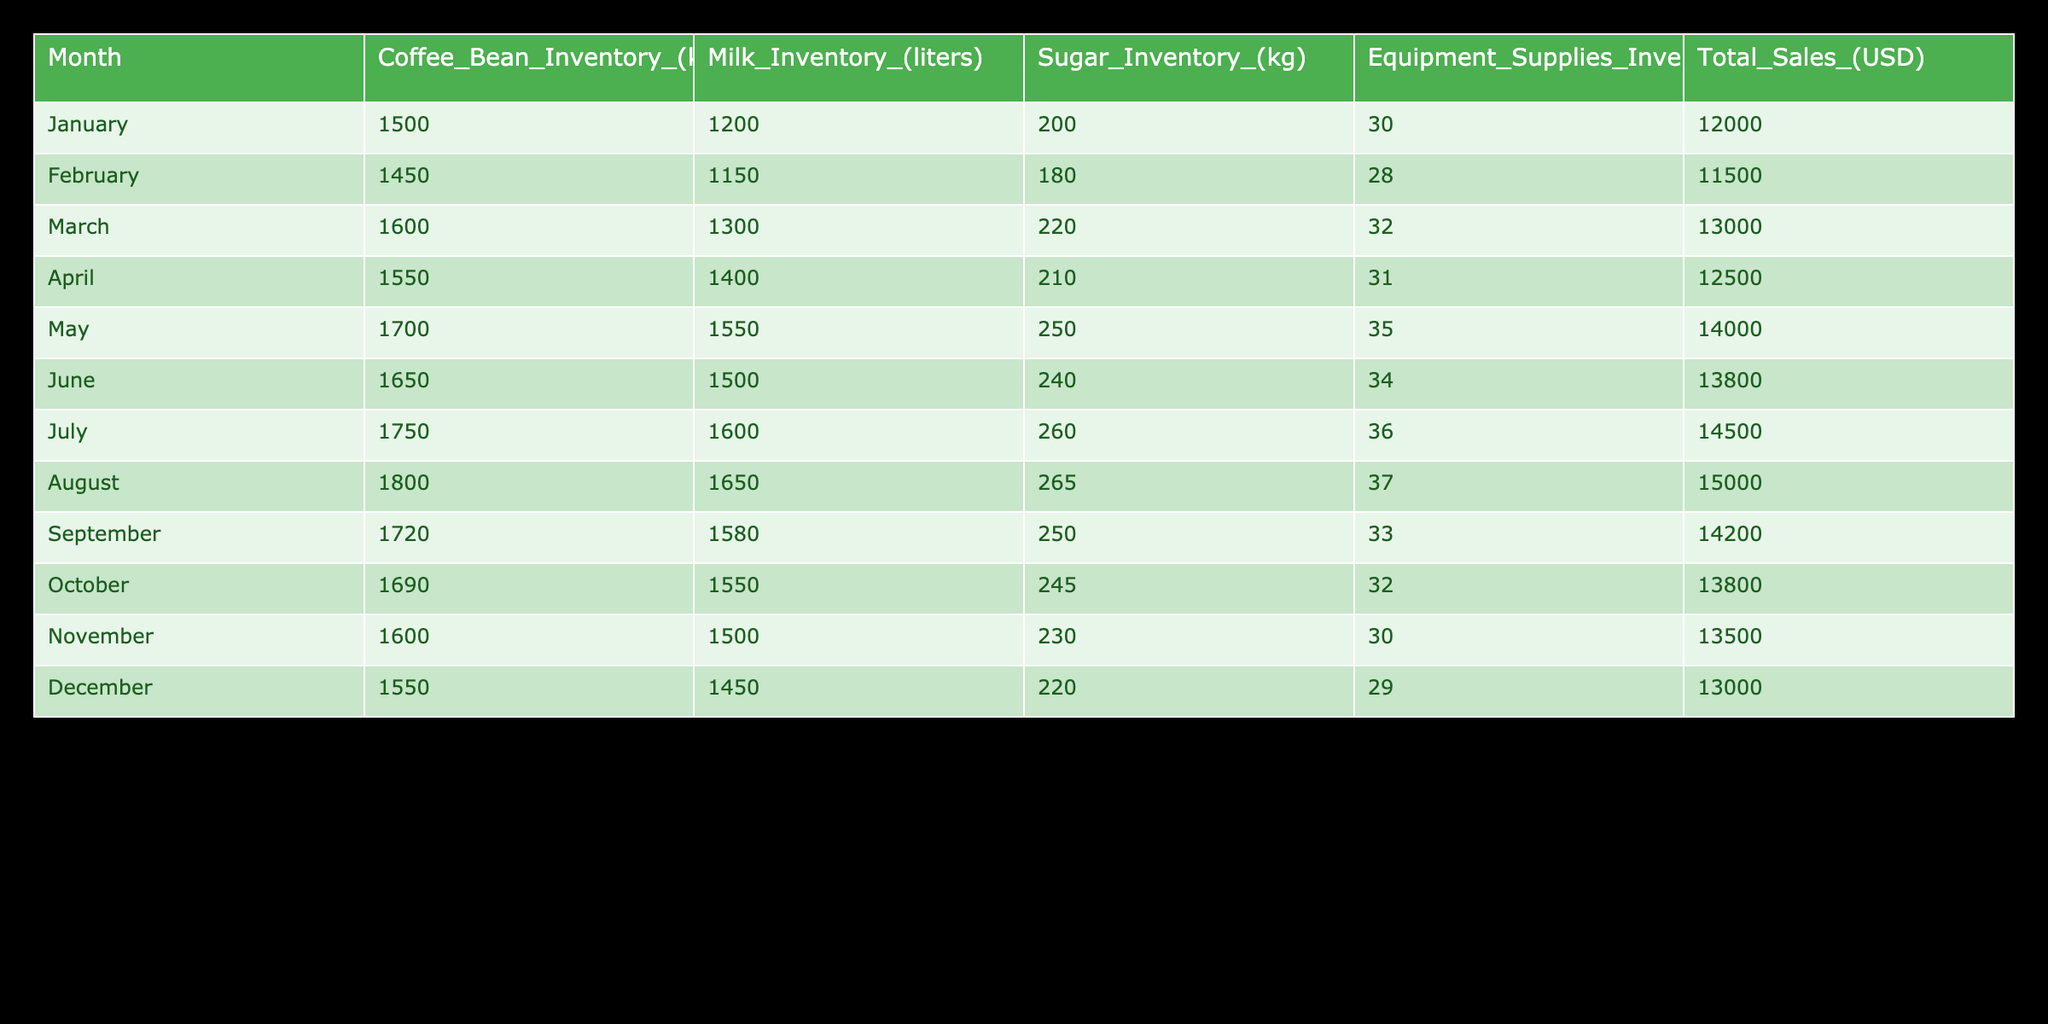What was the coffee bean inventory in May? The table shows the coffee bean inventory for May as 1700 kg, which is directly listed in the May row.
Answer: 1700 kg In which month was the milk inventory the highest? By comparing the milk inventories listed for each month, August has the highest inventory at 1650 liters.
Answer: August What is the total sugar inventory for the first half of the year? To find this, we sum the sugar inventories from January to June: 200 + 180 + 220 + 210 + 250 + 240 = 1300 kg.
Answer: 1300 kg Did the total sales decrease in November compared to October? Looking at the total sales figures, November shows 13500 USD while October shows 13800 USD. Since 13500 is less than 13800, the sales did indeed decrease.
Answer: Yes What is the average coffee bean inventory for the year? Adding up all coffee bean inventories: 1500 + 1450 + 1600 + 1550 + 1700 + 1650 + 1750 + 1800 + 1720 + 1690 + 1600 + 1550 = 18600 kg. There are 12 months, so the average is 18600 / 12 = 1550 kg.
Answer: 1550 kg Was there a month when equipment supplies inventory was at its peak? If so, which month? The maximum value in the equipment supplies column is 37 units in August, which indicates it was the peak month for equipment supplies.
Answer: August How much milk inventory was available in the month with the highest total sales? The highest total sales recorded were in August (15000 USD), and the corresponding milk inventory for that month was 1650 liters.
Answer: 1650 liters Which month experienced an increase in coffee bean inventory compared to the previous month? Examining the coffee bean inventories month-to-month, an increase is seen from June (1650 kg) to July (1750 kg), showing an increase of 100 kg.
Answer: July What is the total inventory of equipment supplies for the second half of the year? Summing the equipment supplies from July to December gives 36 + 37 + 33 + 32 + 30 + 29 = 197 units, indicating this is the total for the latter half of the year.
Answer: 197 units 